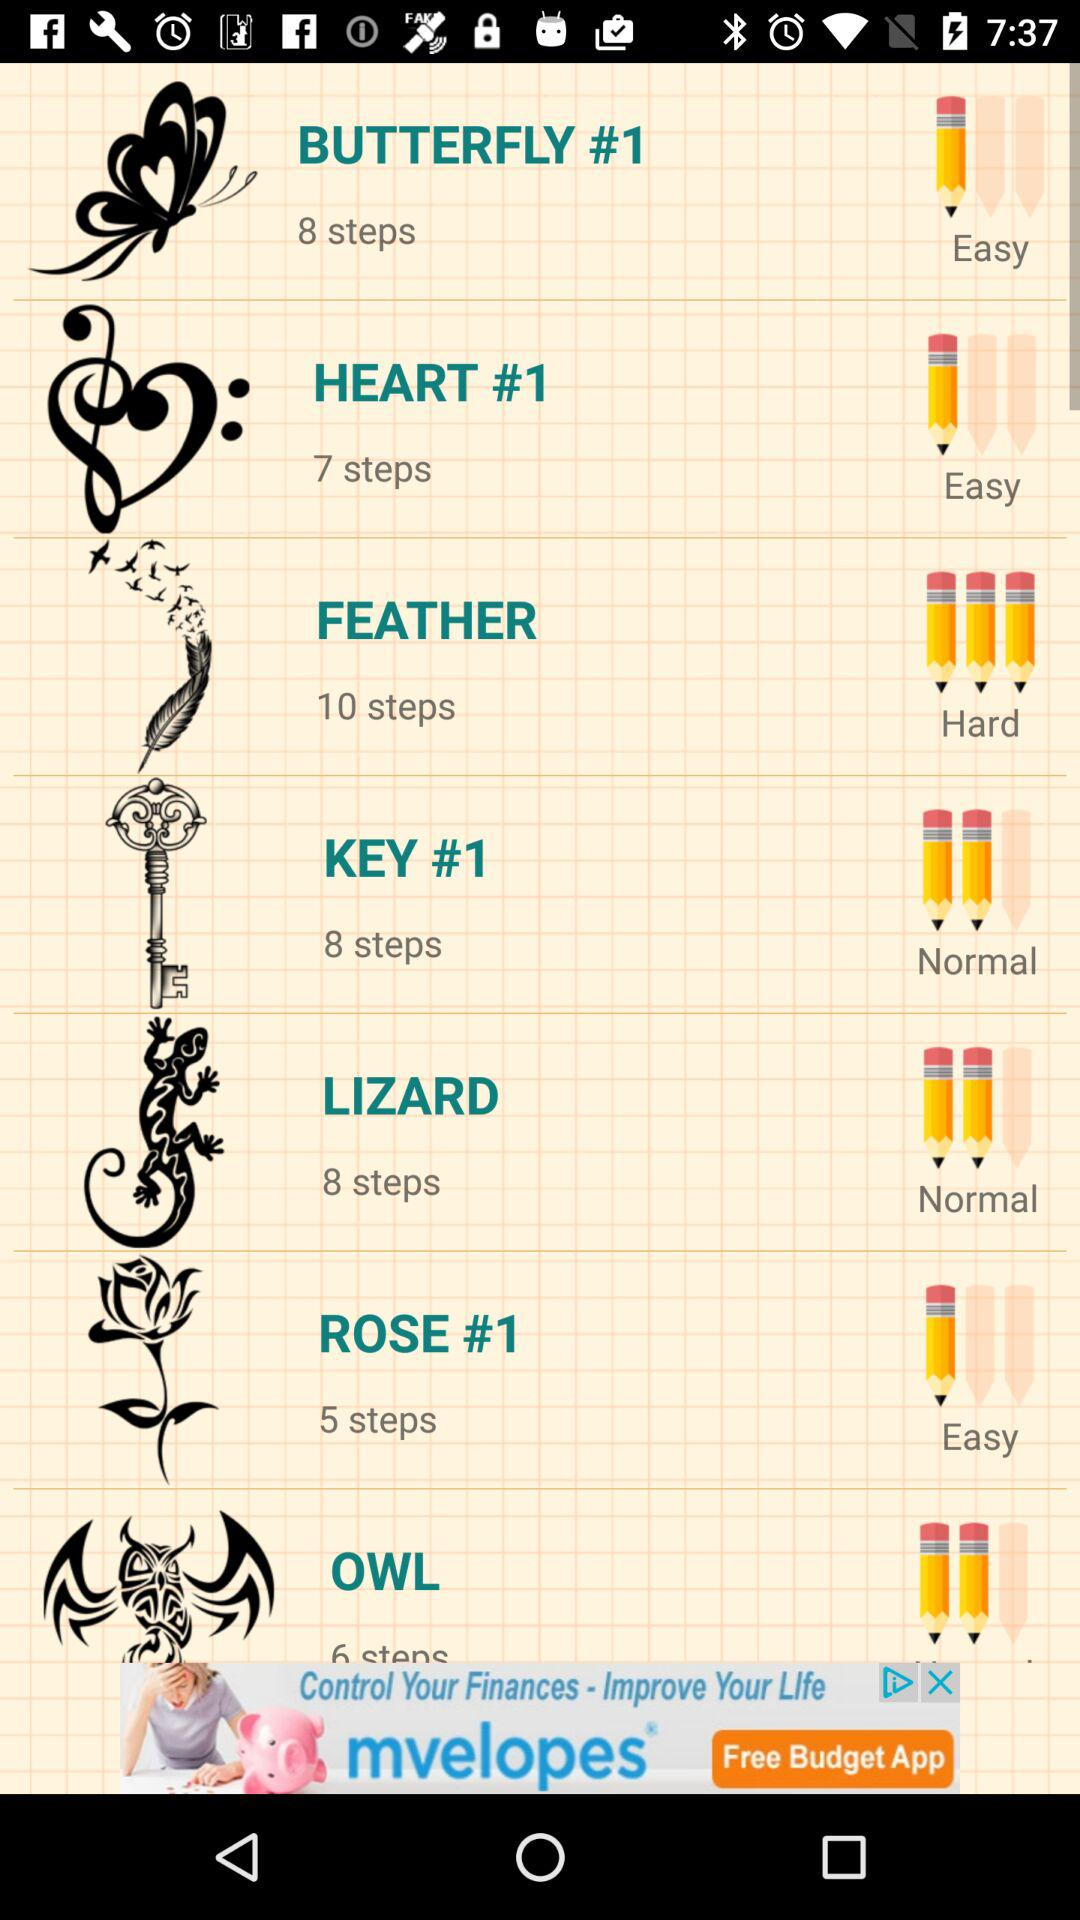What option is a hard step? The hard step is "FEATHER". 